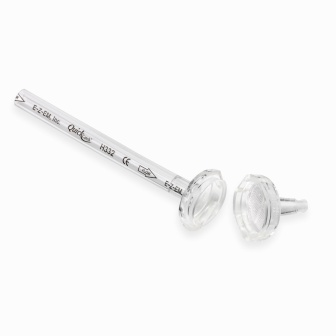Let's discuss the implications of the object's design on its functionality. The object's design, featuring a sleek silver-colored rod and clear faceted plastic knobs at each end, suggests a fusion of functionality and aesthetics. The rod's engravings not only serve as identifiers but also add to its visual charm. The plastic knobs might provide a comfortable grip, making it easy to handle. Such a blend of materials and design indicates potential versatility; the rod could be a decorative piece, a ceremonial item, or a functional tool in various industries such as scientific research or high-precision crafts. The clarity and visibility of the engravings also point towards ease of identification, ensuring that users can quickly ascertain pertinent information about the object. 